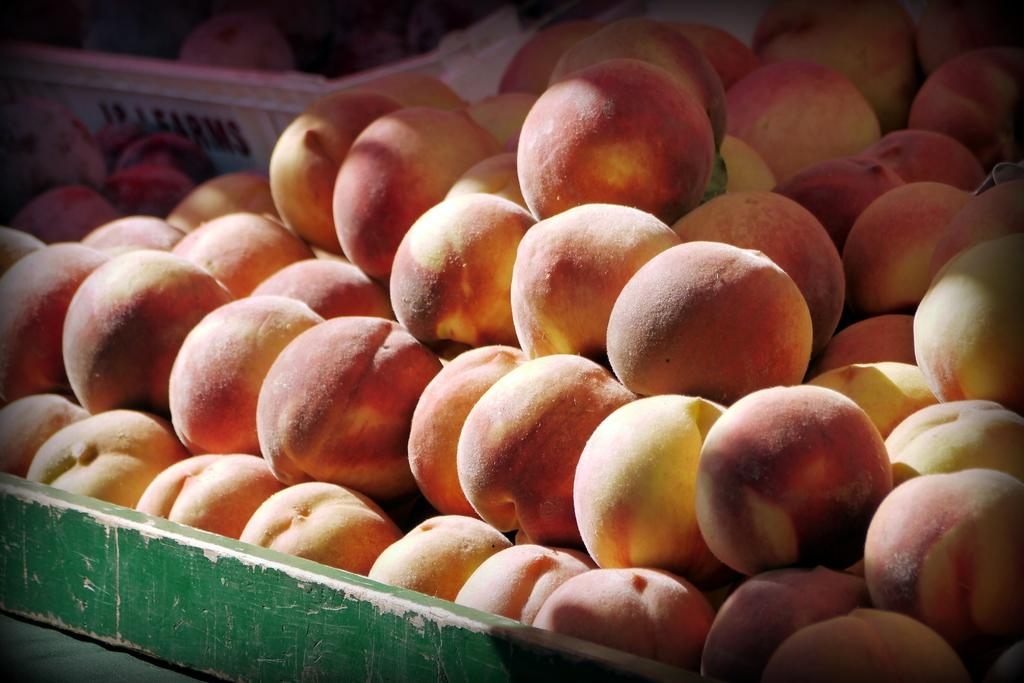What is the main subject of the image? The main subject of the image is many fruits. Where are the fruits located in the image? The fruits are in the center of the image. Is there any container for the fruits in the image? Yes, there is a basket containing some fruits in the image. What type of tank is visible in the image? There is no tank present in the image; it features many fruits and a basket containing some fruits. Who is the guide in the image? There is no guide present in the image. 